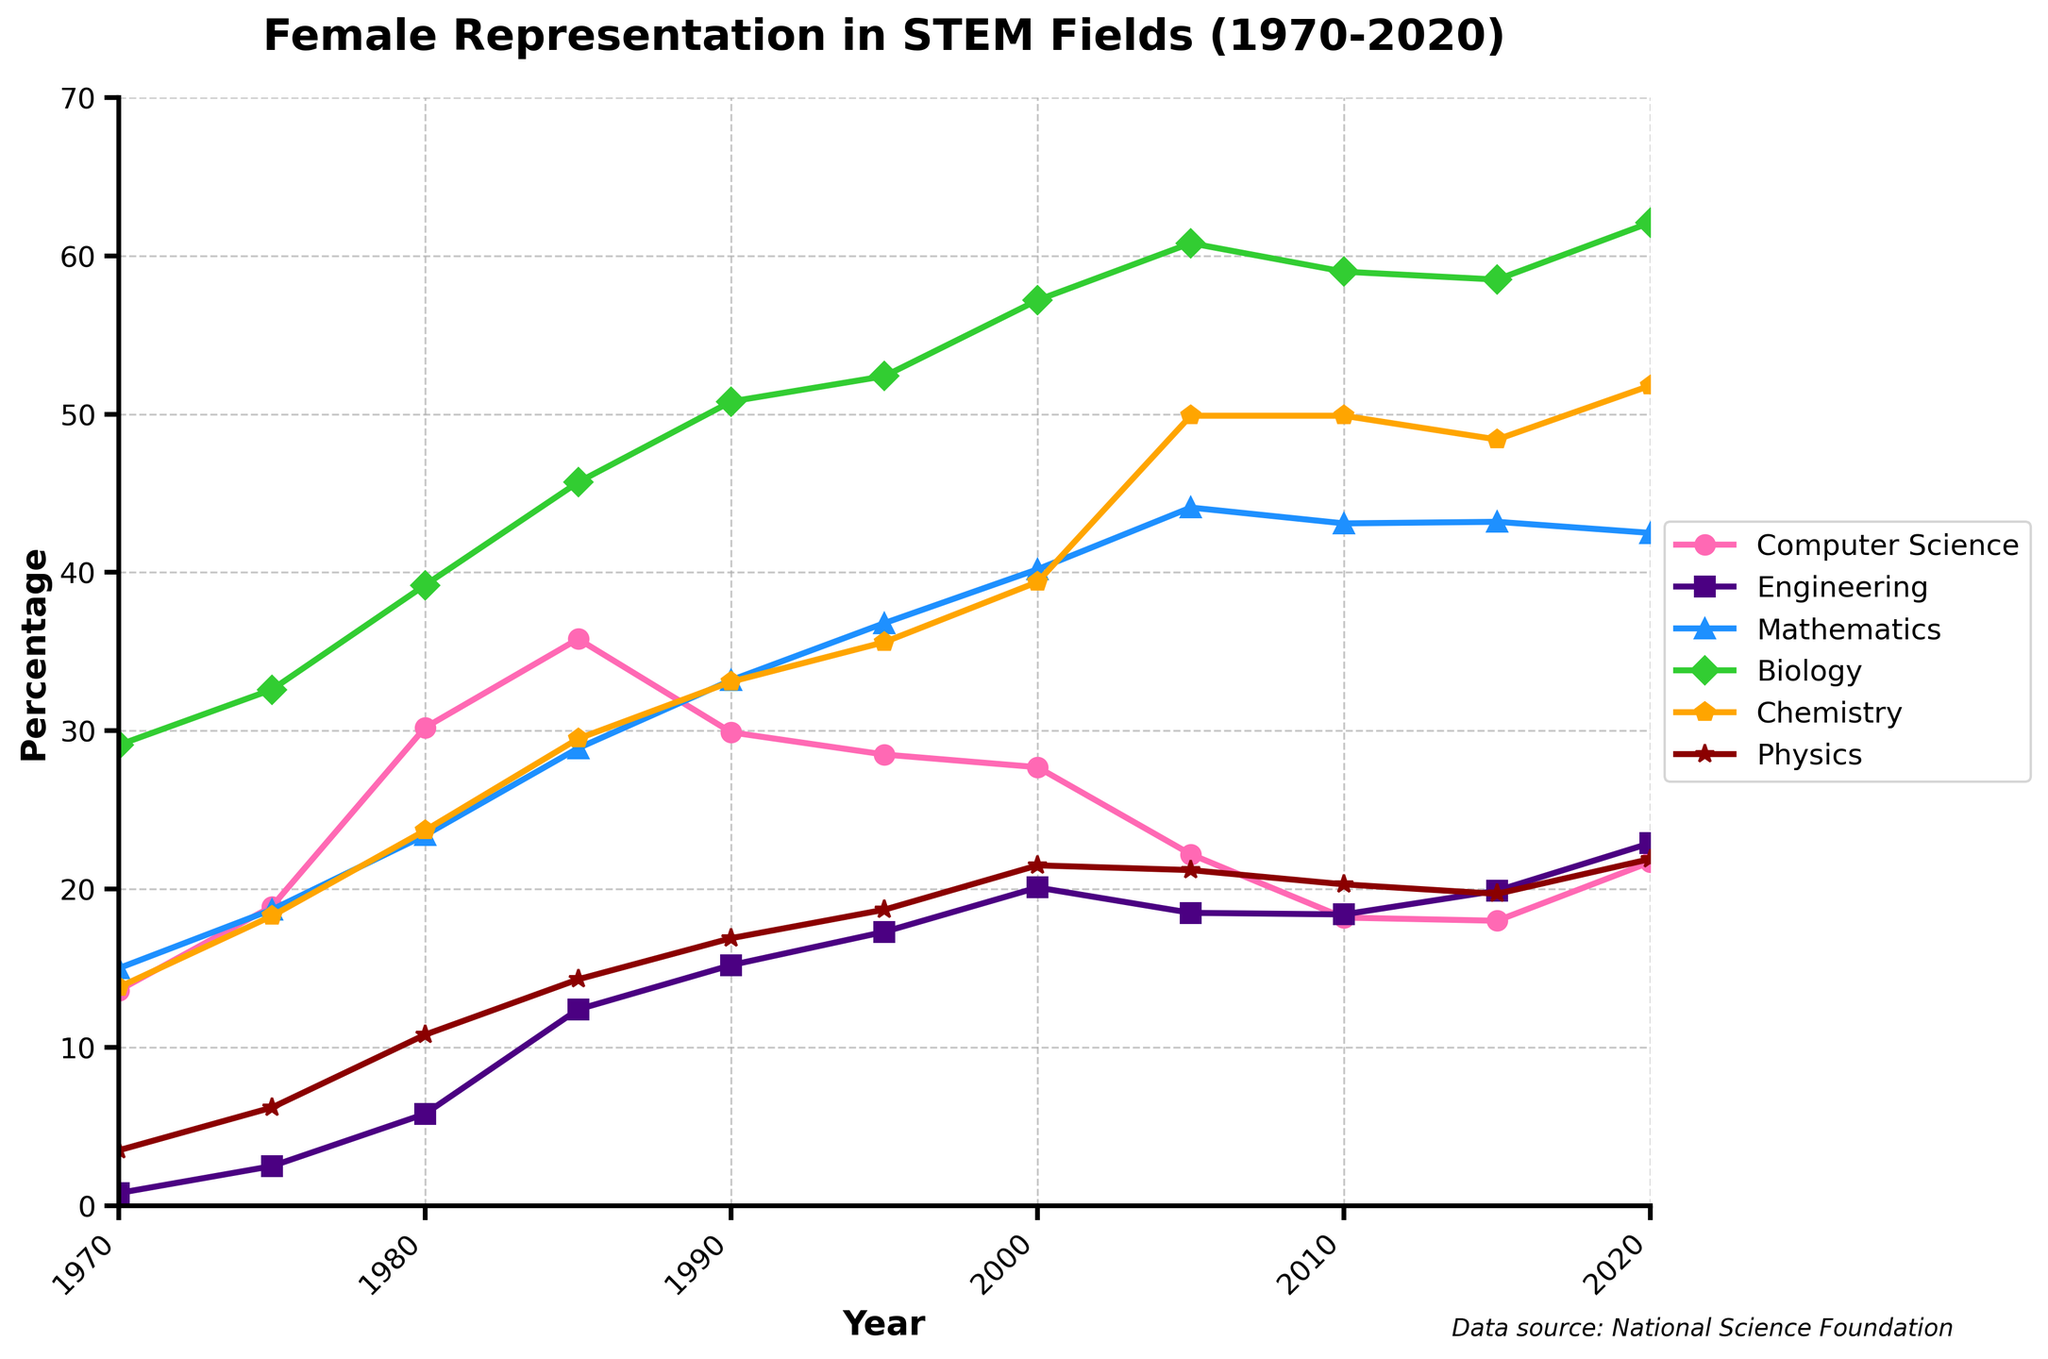Which field had the highest female representation in 1985? By examining the figure for the year 1985, we can see the highest point among the lines is for Biology.
Answer: Biology What is the difference in female representation between Engineering and Physics in 2000? In 2000, the representation for Engineering is about 20.1% and for Physics is about 21.5%. The difference is 21.5 - 20.1 = 1.4%.
Answer: 1.4% Between 1990 and 2020, which field saw the largest growth in female representation? To find the field with the largest growth, compare the values from 1990 and 2020 for each field: Computer Science (29.9-21.7), Engineering (15.2-22.9), Mathematics (33.2-42.5), Biology (50.8-62.1), Chemistry (33.1-51.8), and Physics (16.9-21.9). The largest growth occurs in Biology.
Answer: Biology Which field had the most stable female representation from 2010 to 2020? Observing the lines from 2010 to 2020, the field with the least change or fluctuation is Mathematics.
Answer: Mathematics What was the average female representation in Computer Science over the 50-year period? Sum up the percentages for Computer Science from all years provided and divide by the number of years. (13.6+18.9+30.2+35.8+29.9+28.5+27.7+22.2+18.2+18.0+21.7)/11 = 24.1%.
Answer: 24.1% Which fields had a female representation greater than 50% in 2020? In 2020, check the percentage values to see which are above 50%. Only Biology (62.1%) and Chemistry (51.8%) exceed 50%.
Answer: Biology, Chemistry Did any field experience a decline in female representation from 1985 to 2020? Check the values in 1985 and 2020 for each field: Computer Science (35.8 to 21.7), Engineering (12.4 to 22.9), Mathematics (28.9 to 42.5), Biology (45.7 to 62.1), Chemistry (29.5 to 51.8), and Physics (14.3 to 21.9). Only Computer Science declined.
Answer: Computer Science 